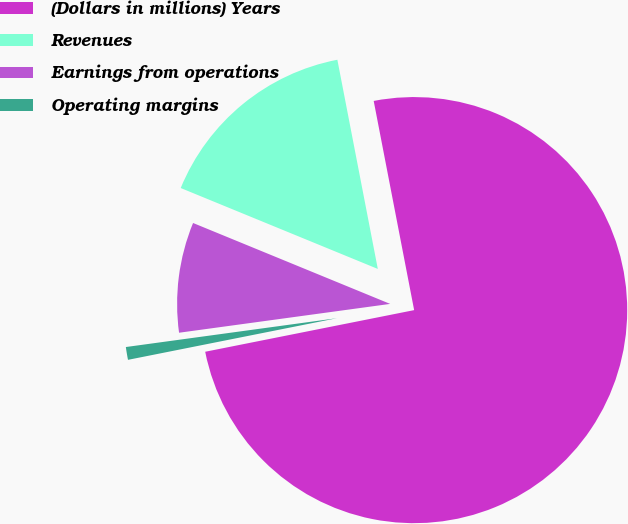<chart> <loc_0><loc_0><loc_500><loc_500><pie_chart><fcel>(Dollars in millions) Years<fcel>Revenues<fcel>Earnings from operations<fcel>Operating margins<nl><fcel>74.91%<fcel>15.76%<fcel>8.36%<fcel>0.97%<nl></chart> 